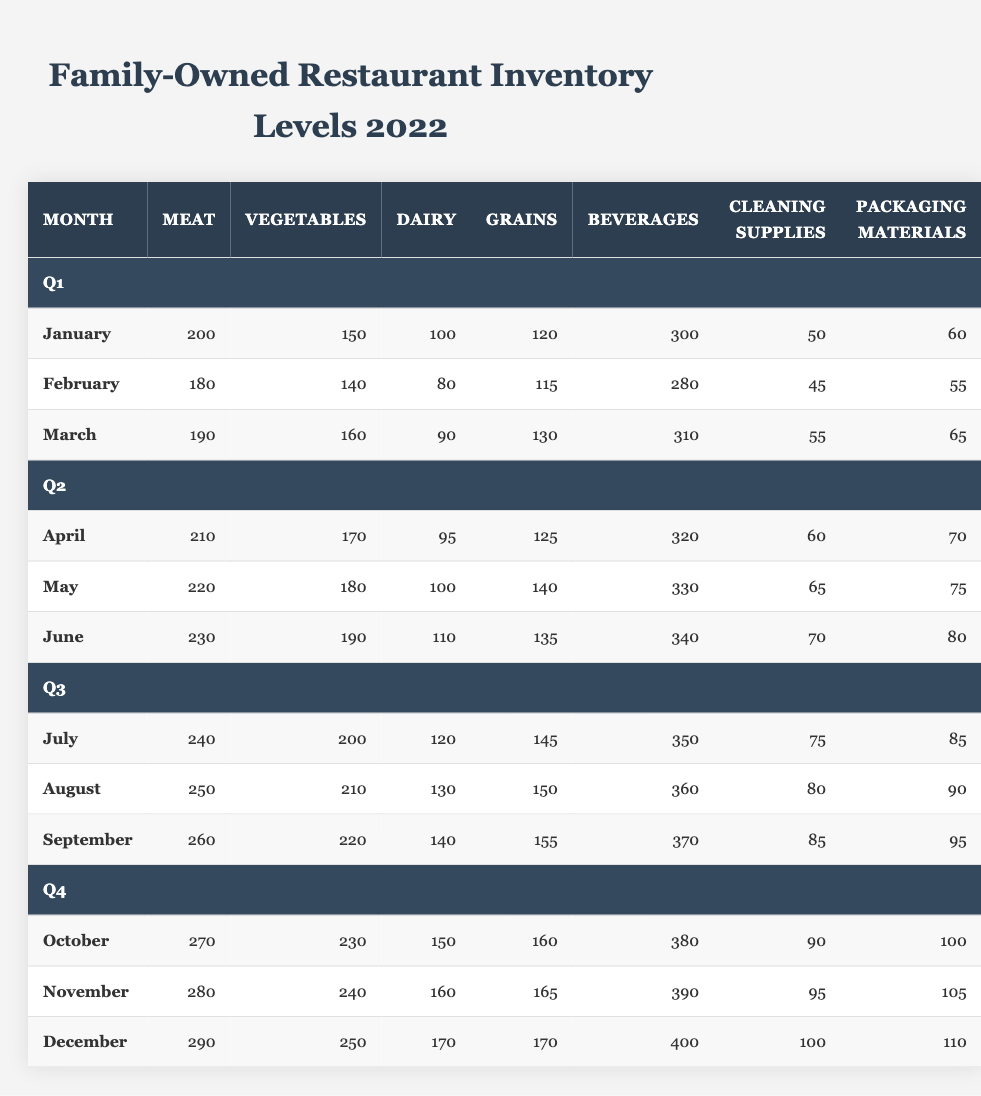What is the inventory level of meat in December? In December, under the food items category, the meat inventory level is listed as 290.
Answer: 290 What was the highest inventory level of dairy recorded in 2022? The table shows the dairy inventory levels for each month; the highest value is 170 in December.
Answer: 170 How many more beverages were available in November compared to January? In November, there were 390 beverages, while in January, there were 300. Subtracting gives 390 - 300 = 90.
Answer: 90 What was the average inventory of vegetables from January to March? Adding the vegetable inventory levels: January (150) + February (140) + March (160) = 450. Dividing by 3 months gives an average of 450 / 3 = 150.
Answer: 150 Is the meat inventory level in April greater than that in February? April has a meat inventory of 210 while February has 180. Since 210 is greater than 180, the answer is yes.
Answer: Yes What is the total inventory of non-food items in June? The non-food items in June consist of beverages (340), cleaning supplies (70), and packaging materials (80). Adding these gives 340 + 70 + 80 = 490.
Answer: 490 Compare the total inventory levels of food items in August and September. In August, the total food inventory (meat 250 + vegetables 210 + dairy 130 + grains 150) equals 740. In September (meat 260 + vegetables 220 + dairy 140 + grains 155), it equals 775. Thus, September has more by 775 - 740 = 35.
Answer: September has 35 more What month had the lowest total inventory of cleaning supplies? Checking the cleaning supplies column, January has 50, which is the lowest compared to other months.
Answer: January What was the percentage increase in the inventory of grains from January to December? The grains inventory in January is 120 and in December is 170. The increase is 170 - 120 = 50, so the percentage increase is (50 / 120) * 100 = 41.67%.
Answer: 41.67% Which month saw an increase in dairy inventory compared to the previous month, and what was that increase? Comparing the dairy inventory month over month, the only increase occurs from November (160) to December (170), an increase of 10.
Answer: December; 10 What are the total food items and total non-food items inventory levels in July? The food items in July total (meat 240 + vegetables 200 + dairy 120 + grains 145) = 705. The non-food items total (beverages 350 + cleaning supplies 75 + packaging materials 85) = 510.
Answer: Food: 705, Non-food: 510 